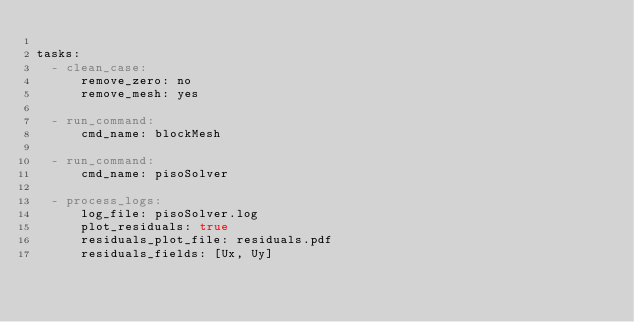Convert code to text. <code><loc_0><loc_0><loc_500><loc_500><_YAML_>
tasks:
  - clean_case:
      remove_zero: no
      remove_mesh: yes

  - run_command:
      cmd_name: blockMesh

  - run_command:
      cmd_name: pisoSolver

  - process_logs:
      log_file: pisoSolver.log
      plot_residuals: true
      residuals_plot_file: residuals.pdf
      residuals_fields: [Ux, Uy]
</code> 